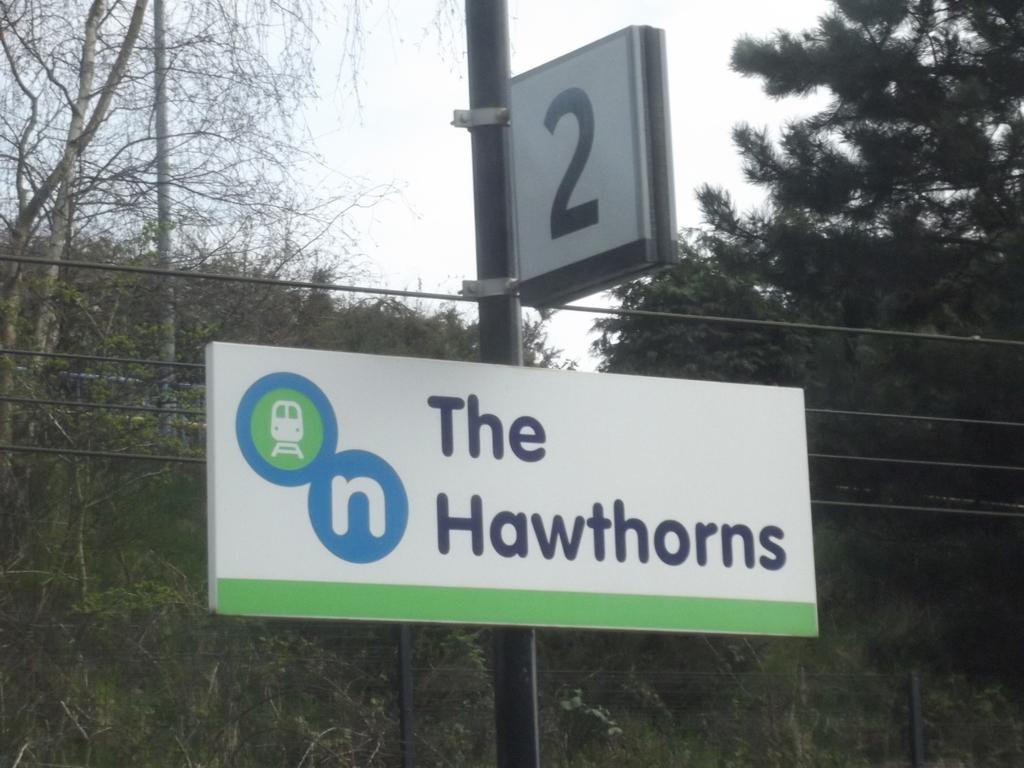<image>
Provide a brief description of the given image. A sign with the number 2 on it above a sign with The Hawthorns on it. 